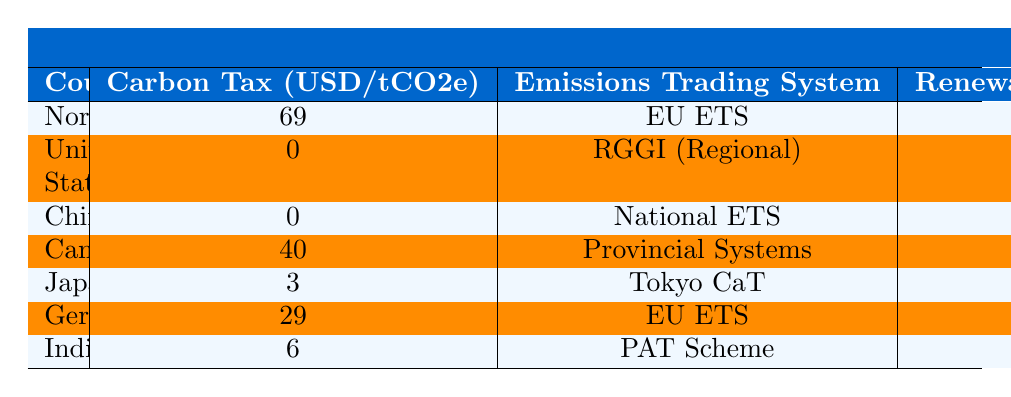What is the carbon tax imposed by Norway? Norway has a carbon tax of 69 USD per ton of CO2 equivalent, as stated directly in the table under the column "Carbon Tax (USD/tCO2e)."
Answer: 69 USD/tCO2e Which country has the highest renewable energy target? Canada has the highest renewable energy target at 90%, as indicated in the "Renewable Energy Target (%)" column, while others like Norway and Germany have lower percentages.
Answer: Canada Do any countries have a carbon tax of zero? Both the United States and China have a carbon tax of zero, which is clearly noted in the "Carbon Tax (USD/tCO2e)" column.
Answer: Yes What are the vehicle emission standards in Germany? Germany's vehicle emission standards are classified as "Euro 6," which can be found in the "Vehicle Emission Standards" column.
Answer: Euro 6 How many countries have an industrial emissions cap? Based on the data, Norway, China, Canada, Germany, and India have an industrial emissions cap, totaling five countries from the "Industrial Emissions Cap" column.
Answer: Five Which country has the most lenient methane regulations? The country with lenient methane regulations is China, as listed in the "Methane Regulations" column where it states "Lenient."
Answer: China What is the average carbon tax of the countries in the table? The average carbon tax can be calculated by adding up the carbon taxes of the countries (69 + 0 + 0 + 40 + 3 + 29 + 6) = 147, and dividing by 7 (total countries) resulting in an average of 21. Thus, 147/7 = 21.
Answer: 21 USD/tCO2e Which country aims for a net-zero target year of 2070? The table indicates that India has set its net-zero target year for 2070, which can be referenced in the "Net-Zero Target Year" column.
Answer: India How does Canada's carbon offset allowance compare to Norway's? Canada has a carbon offset allowance of 8%, while Norway allows for 10%. The difference shows that Norway allows slightly more compensation for carbon emissions than Canada.
Answer: Norway allows more Out of Norway, Japan, and India, which country has the strictest methane regulations? Norway has strict methane regulations, as noted in the "Methane Regulations" column, compared to Japan's moderate and India's lenient regulations.
Answer: Norway 